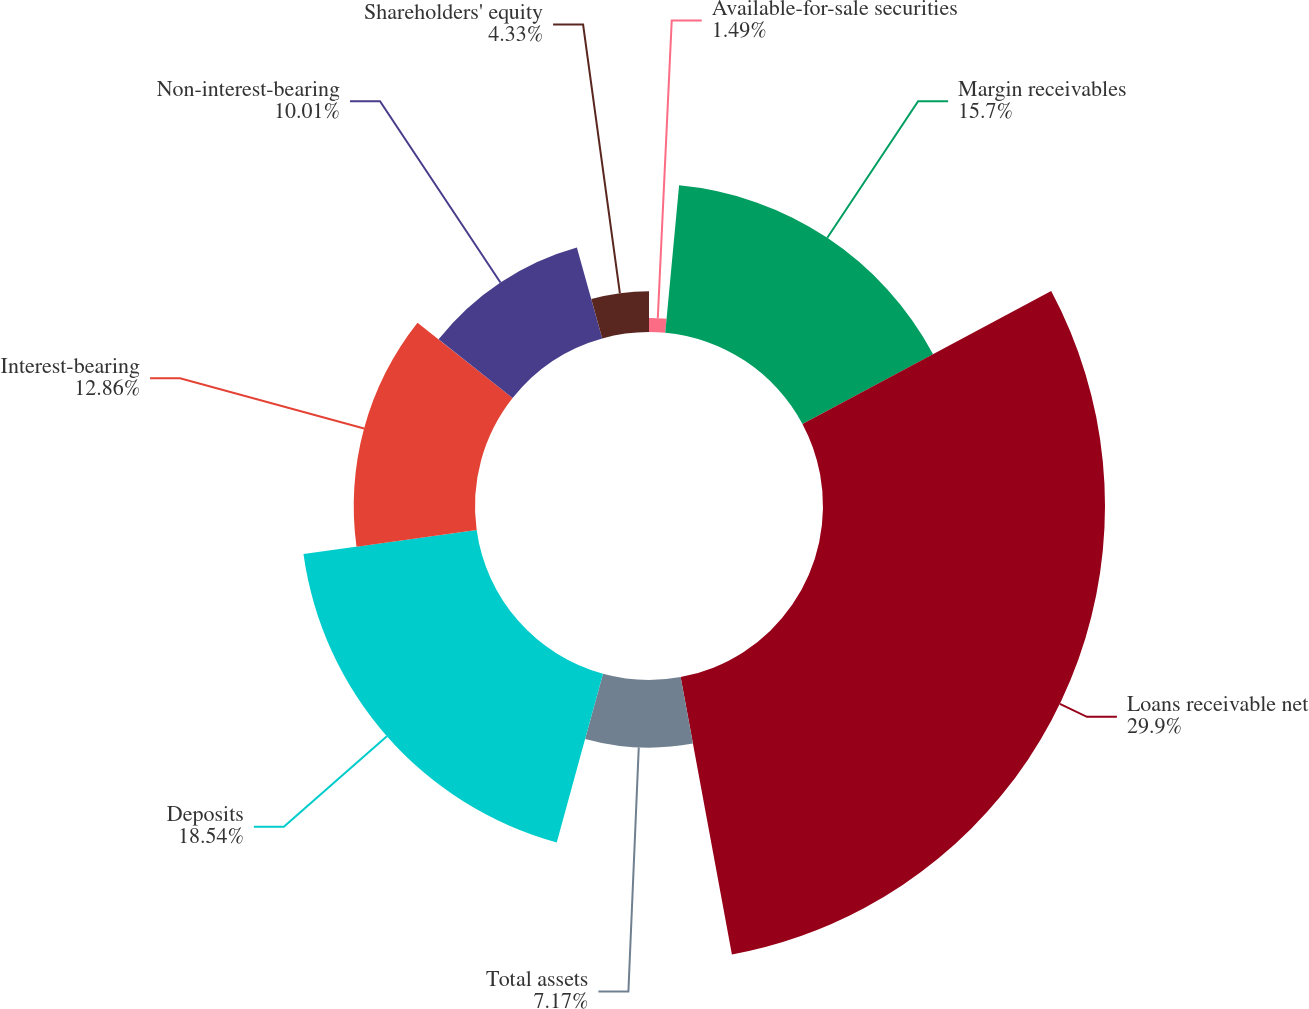<chart> <loc_0><loc_0><loc_500><loc_500><pie_chart><fcel>Available-for-sale securities<fcel>Margin receivables<fcel>Loans receivable net<fcel>Total assets<fcel>Deposits<fcel>Interest-bearing<fcel>Non-interest-bearing<fcel>Shareholders' equity<nl><fcel>1.49%<fcel>15.7%<fcel>29.9%<fcel>7.17%<fcel>18.54%<fcel>12.86%<fcel>10.01%<fcel>4.33%<nl></chart> 